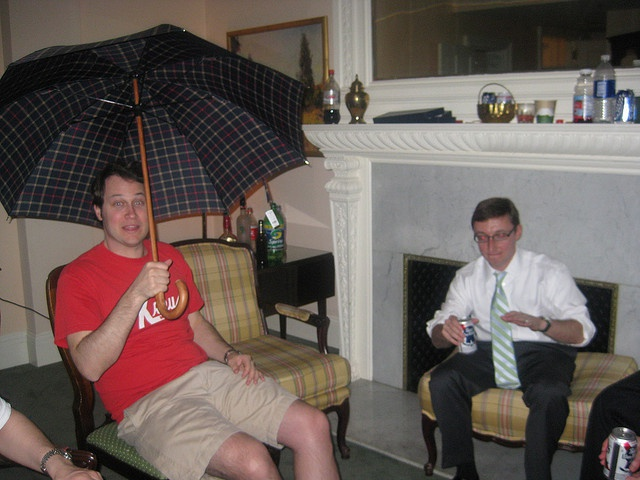Describe the objects in this image and their specific colors. I can see umbrella in black, maroon, and gray tones, people in black, brown, darkgray, and gray tones, people in black, lightgray, darkgray, and gray tones, chair in black and gray tones, and bottle in black, gray, darkgray, and maroon tones in this image. 